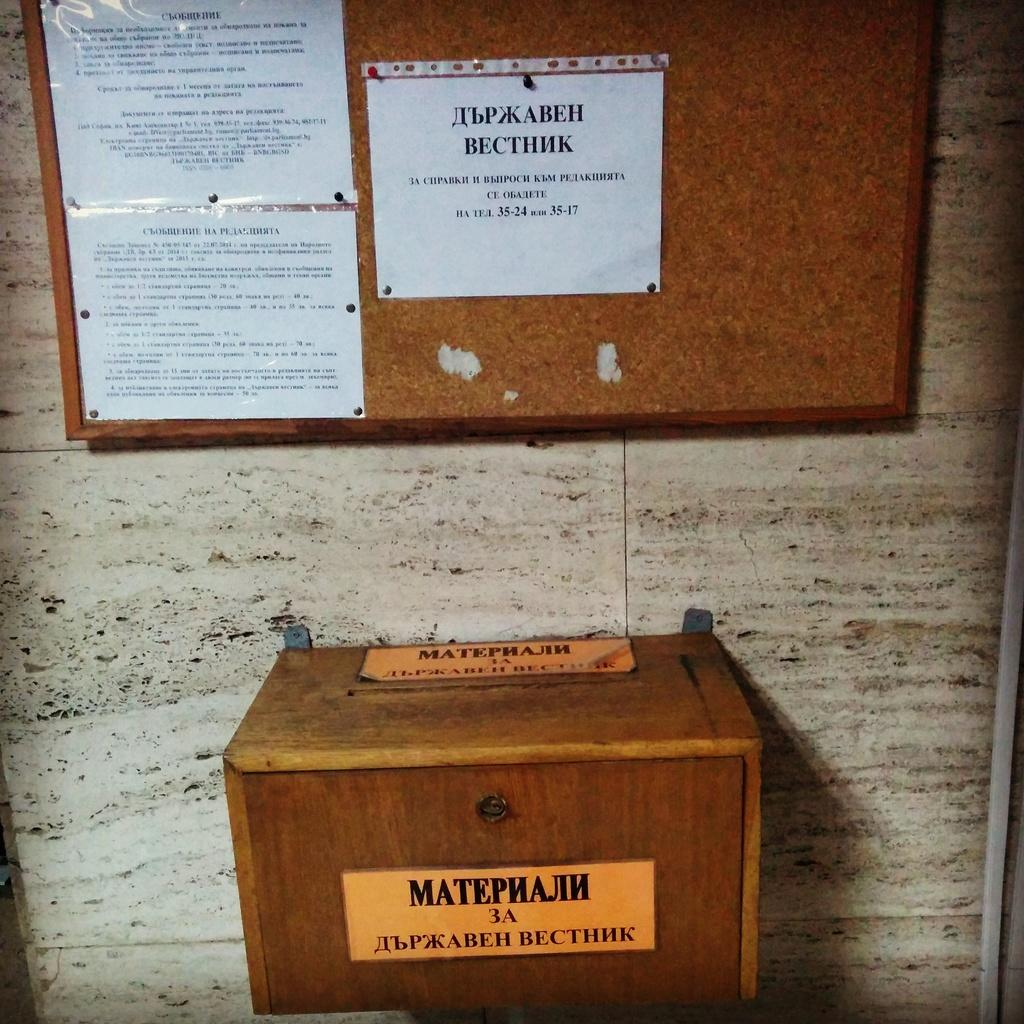Provide a one-sentence caption for the provided image. A wooden box with a label on the front of the box saying MatephajIh 3A with a bulletin board behind it. 